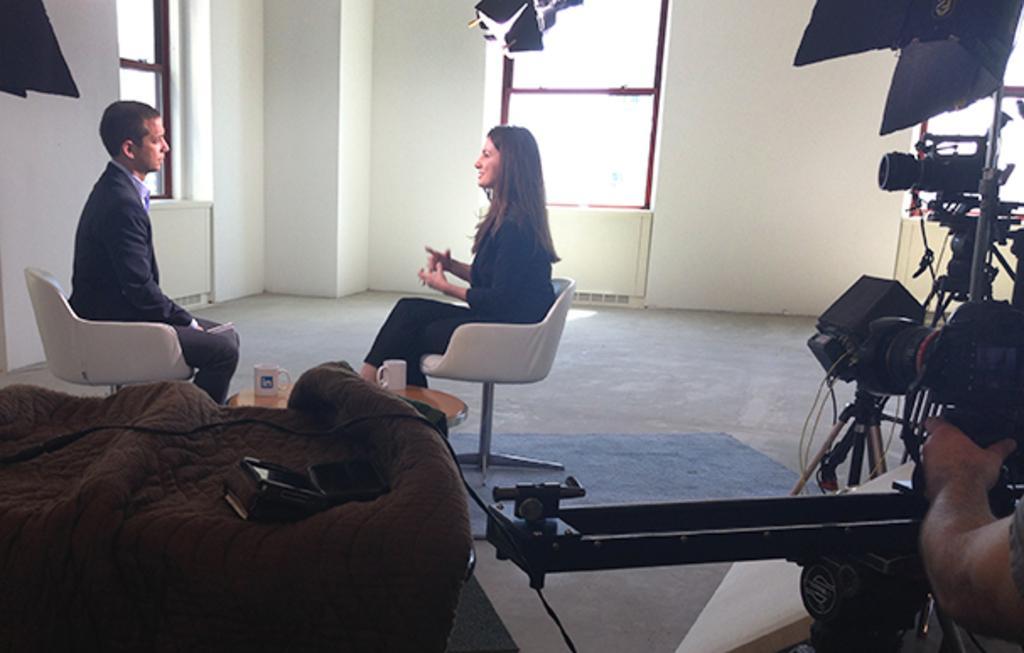Could you give a brief overview of what you see in this image? In this image I can see two people sitting on the chairs and there is a camera in this room. 